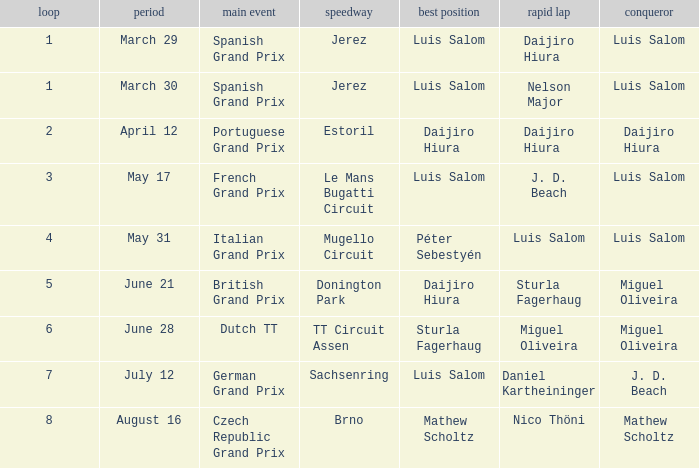Parse the full table. {'header': ['loop', 'period', 'main event', 'speedway', 'best position', 'rapid lap', 'conqueror'], 'rows': [['1', 'March 29', 'Spanish Grand Prix', 'Jerez', 'Luis Salom', 'Daijiro Hiura', 'Luis Salom'], ['1', 'March 30', 'Spanish Grand Prix', 'Jerez', 'Luis Salom', 'Nelson Major', 'Luis Salom'], ['2', 'April 12', 'Portuguese Grand Prix', 'Estoril', 'Daijiro Hiura', 'Daijiro Hiura', 'Daijiro Hiura'], ['3', 'May 17', 'French Grand Prix', 'Le Mans Bugatti Circuit', 'Luis Salom', 'J. D. Beach', 'Luis Salom'], ['4', 'May 31', 'Italian Grand Prix', 'Mugello Circuit', 'Péter Sebestyén', 'Luis Salom', 'Luis Salom'], ['5', 'June 21', 'British Grand Prix', 'Donington Park', 'Daijiro Hiura', 'Sturla Fagerhaug', 'Miguel Oliveira'], ['6', 'June 28', 'Dutch TT', 'TT Circuit Assen', 'Sturla Fagerhaug', 'Miguel Oliveira', 'Miguel Oliveira'], ['7', 'July 12', 'German Grand Prix', 'Sachsenring', 'Luis Salom', 'Daniel Kartheininger', 'J. D. Beach'], ['8', 'August 16', 'Czech Republic Grand Prix', 'Brno', 'Mathew Scholtz', 'Nico Thöni', 'Mathew Scholtz']]} Luis Salom had the fastest lap on which circuits?  Mugello Circuit. 